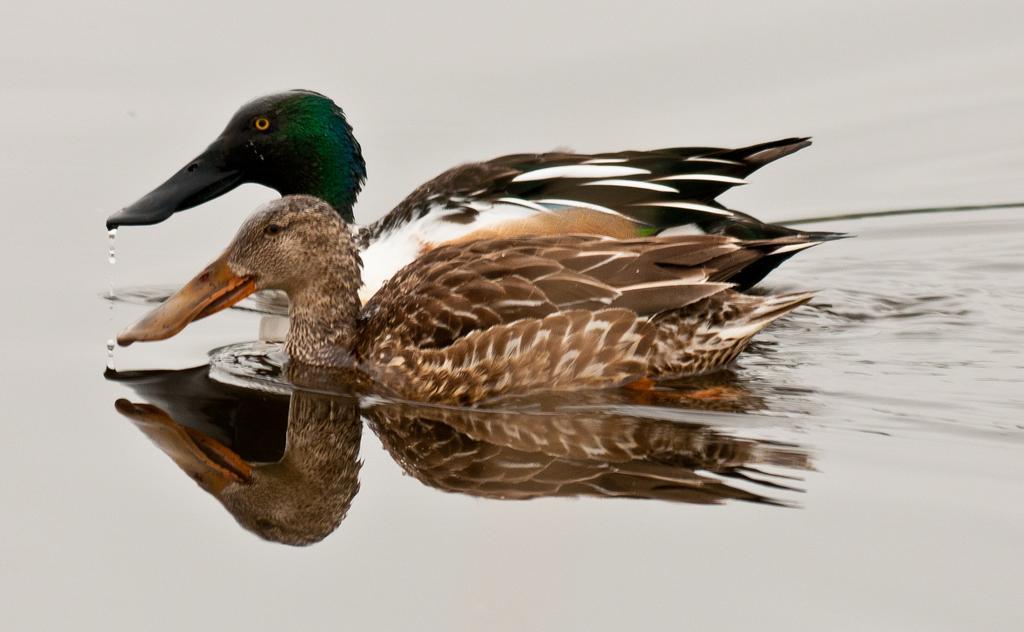Please provide a concise description of this image. In this image there are two ducks swimming on the water. Around them there is the water. At the bottom there is reflection of the ducks on the water. There are water droplets in front of them in the air. 